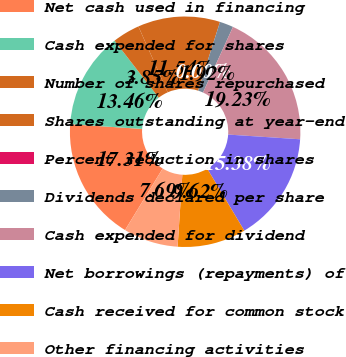Convert chart. <chart><loc_0><loc_0><loc_500><loc_500><pie_chart><fcel>Net cash used in financing<fcel>Cash expended for shares<fcel>Number of shares repurchased<fcel>Shares outstanding at year-end<fcel>Percent reduction in shares<fcel>Dividends declared per share<fcel>Cash expended for dividend<fcel>Net borrowings (repayments) of<fcel>Cash received for common stock<fcel>Other financing activities<nl><fcel>17.31%<fcel>13.46%<fcel>3.85%<fcel>11.54%<fcel>0.0%<fcel>1.92%<fcel>19.23%<fcel>15.38%<fcel>9.62%<fcel>7.69%<nl></chart> 